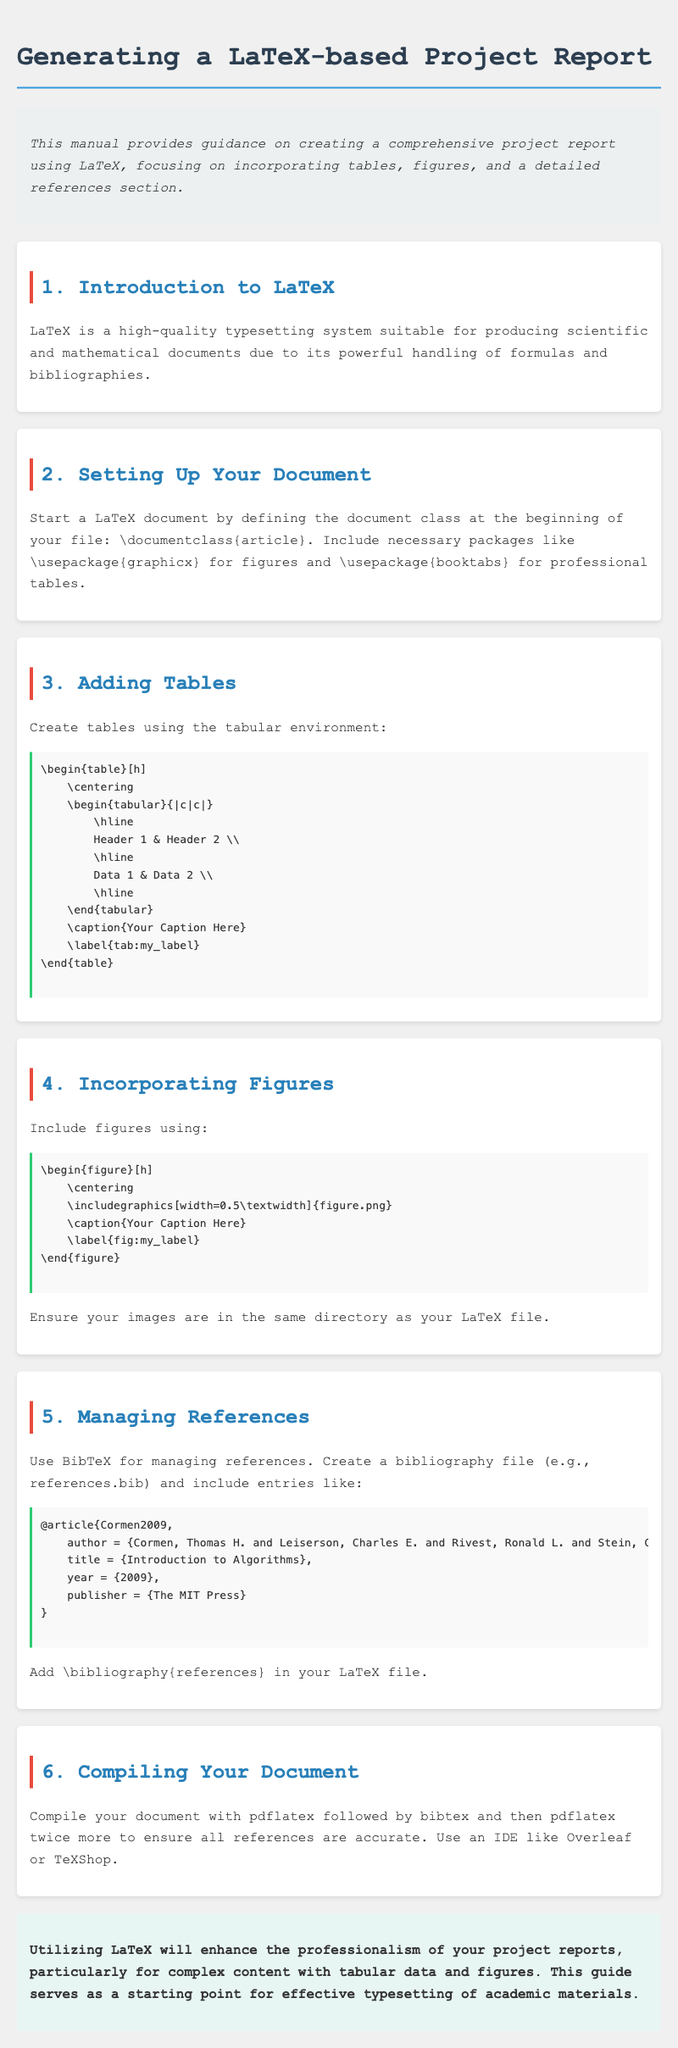What is the title of this manual? The title is provided in the document header, which is "Generating a LaTeX-based Project Report".
Answer: Generating a LaTeX-based Project Report What package is necessary for figures? The document states that the package needed for figures is mentioned in the section on setting up the document, which is "graphicx".
Answer: graphicx What is the correct command to start a LaTeX document? The document specifies that the command to start a LaTeX document is provided in the second section, which is "\documentclass{article}".
Answer: \documentclass{article} How do you add a label to a table? The process for adding a label to a table is detailed in the section "Adding Tables," where it shows using the command "\label{tab:my_label}".
Answer: \label{tab:my_label} Which file type is needed for images in LaTeX? The section on incorporating figures indicates the required image file type to be mentioned for adding images, which is "figure.png".
Answer: figure.png What should you add to your LaTeX file to include the bibliography? The document mentions that to include the bibliography, you should add "\bibliography{references}".
Answer: \bibliography{references} How many times should you run pdflatex while compiling? The section on compiling your document specifies that pdflatex should be run twice more after bibtex, making a total of three times.
Answer: twice more What type of document is this manual focused on creating? The introduction identifies the type of document as a "comprehensive project report".
Answer: comprehensive project report What background color is used for the overview section? The overview section's color is described in the style as "background-color: #ecf0f1;".
Answer: #ecf0f1 